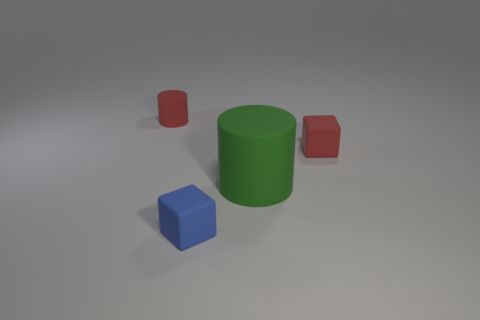How many small blue matte things are to the left of the small block to the left of the tiny red object in front of the small cylinder?
Your answer should be compact. 0. Are there fewer big gray matte things than cylinders?
Your response must be concise. Yes. There is a small thing in front of the large green thing; does it have the same shape as the red matte thing that is in front of the small red matte cylinder?
Give a very brief answer. Yes. The small matte cylinder is what color?
Offer a terse response. Red. What number of matte objects are cubes or blue things?
Offer a very short reply. 2. There is a small object that is the same shape as the big object; what is its color?
Offer a very short reply. Red. Are there any small matte blocks?
Keep it short and to the point. Yes. Do the red object right of the small red cylinder and the cylinder on the right side of the small red cylinder have the same material?
Keep it short and to the point. Yes. What shape is the tiny thing that is the same color as the tiny matte cylinder?
Your response must be concise. Cube. What number of objects are either rubber cylinders that are to the left of the green rubber cylinder or tiny red things on the left side of the big rubber thing?
Make the answer very short. 1. 